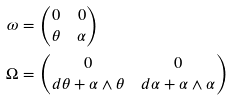<formula> <loc_0><loc_0><loc_500><loc_500>\omega & = \begin{pmatrix} 0 & 0 \\ \theta & \alpha \end{pmatrix} \\ \Omega & = \begin{pmatrix} 0 & 0 \\ d \theta + \alpha \wedge \theta & d \alpha + \alpha \wedge \alpha \end{pmatrix}</formula> 